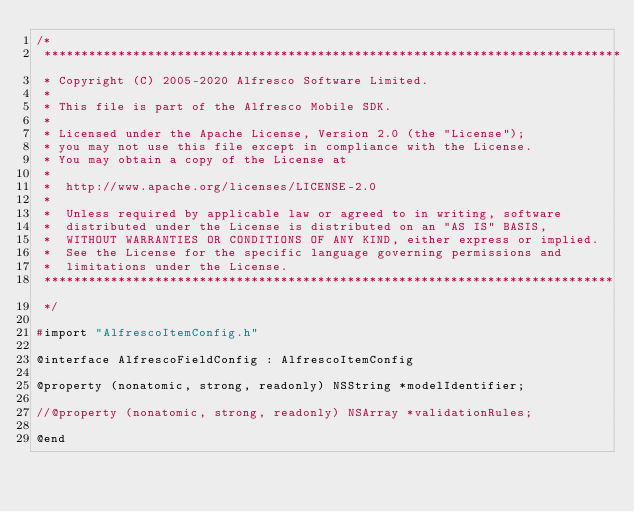Convert code to text. <code><loc_0><loc_0><loc_500><loc_500><_C_>/*
 ******************************************************************************
 * Copyright (C) 2005-2020 Alfresco Software Limited.
 *
 * This file is part of the Alfresco Mobile SDK.
 *
 * Licensed under the Apache License, Version 2.0 (the "License");
 * you may not use this file except in compliance with the License.
 * You may obtain a copy of the License at
 *
 *  http://www.apache.org/licenses/LICENSE-2.0
 *
 *  Unless required by applicable law or agreed to in writing, software
 *  distributed under the License is distributed on an "AS IS" BASIS,
 *  WITHOUT WARRANTIES OR CONDITIONS OF ANY KIND, either express or implied.
 *  See the License for the specific language governing permissions and
 *  limitations under the License.
 *****************************************************************************
 */

#import "AlfrescoItemConfig.h"

@interface AlfrescoFieldConfig : AlfrescoItemConfig

@property (nonatomic, strong, readonly) NSString *modelIdentifier;

//@property (nonatomic, strong, readonly) NSArray *validationRules;

@end
</code> 